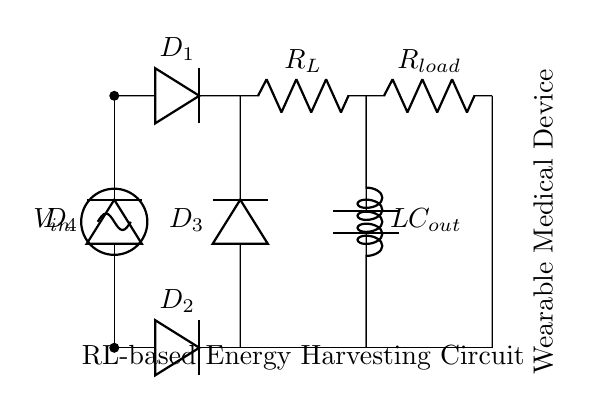What is the input voltage in this circuit? The input voltage is labeled as V_in, indicating the voltage source supplying the circuit.
Answer: V_in What type of diode is used for D1? The diode D1 is shown as a standard diode symbol, indicating its function as a rectifier in the circuit.
Answer: Standard diode How many diodes are present in the circuit? There are four diodes (D1, D2, D3, and D4) visualized in the circuit, identified by their labels.
Answer: Four What are the values of the components connected in parallel to the output capacitor? The output capacitor is connected in parallel to the load resistor and the inductor, creating a pathway for current.
Answer: Load resistor and inductor What is the purpose of the inductor in this circuit? The inductor in an RL circuit stores energy in a magnetic field when current flows through it, which helps smooth out the current and stabilize the output voltage.
Answer: Store energy Explain the function of the rectifier section of this circuit. The rectifier section, consisting of the four diodes, converts the AC input voltage from V_in into a DC output voltage. The arrangement of diodes ensures that current flows in one direction only, creating a proper DC output suitable for electronic devices. This helps in powering the wearable medical device effectively.
Answer: Convert AC to DC What will happen if the inductor's value increases? Increasing the inductor's value will result in a higher energy storage capability and potentially smoother current flow; however, it could also affect the circuit's timing characteristics and response speed, potentially leading to slower transient responses.
Answer: Higher energy storage 